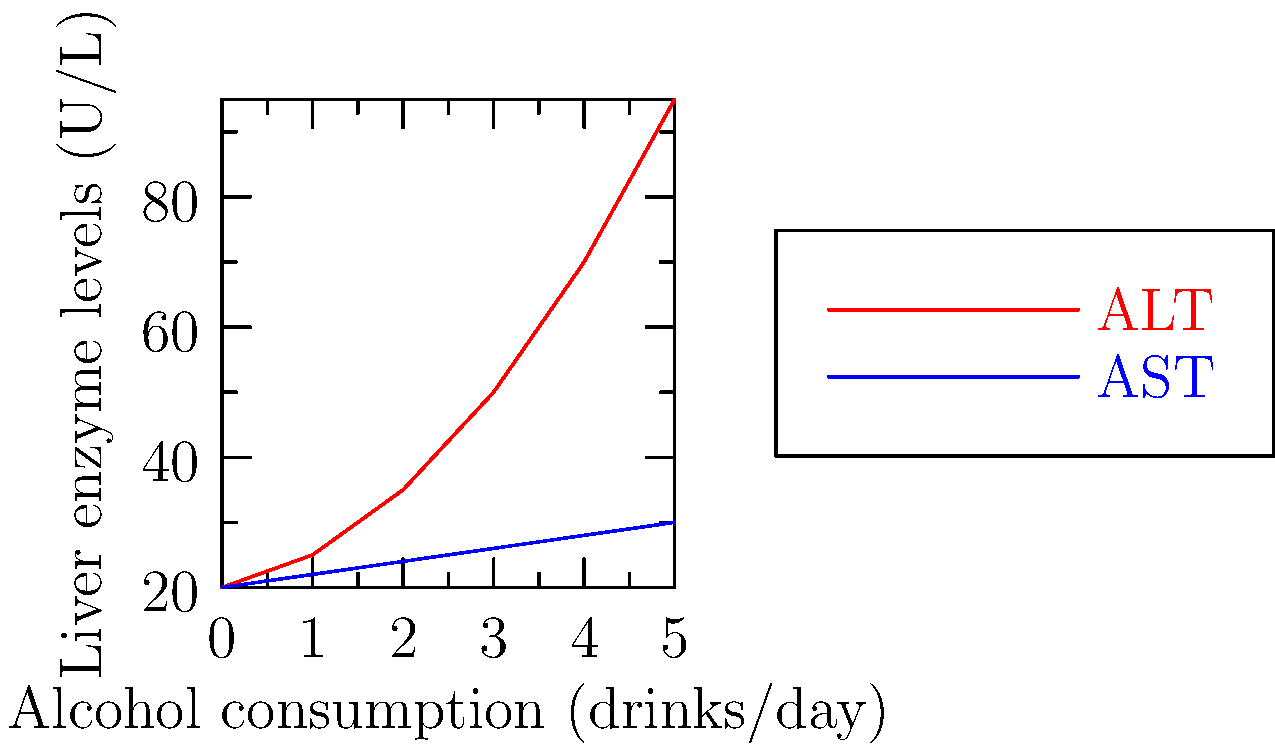Analyze the graph showing the relationship between alcohol consumption and liver enzyme levels (ALT and AST). What conclusion can be drawn about the impact of increasing alcohol intake on liver health? To analyze this graph and draw conclusions about liver health, we need to consider the following steps:

1. Identify the variables:
   - X-axis: Alcohol consumption (drinks/day)
   - Y-axis: Liver enzyme levels (U/L)
   - Red line: ALT (Alanine Aminotransferase)
   - Blue line: AST (Aspartate Aminotransferase)

2. Observe the trends:
   - ALT (red line): Shows a sharp increase as alcohol consumption increases
   - AST (blue line): Shows a gradual increase as alcohol consumption increases

3. Interpret the enzyme changes:
   - ALT and AST are enzymes found primarily in the liver
   - Elevated levels of these enzymes indicate liver cell damage or inflammation

4. Analyze the relationship:
   - As alcohol consumption increases, both ALT and AST levels rise
   - ALT shows a more dramatic increase compared to AST
   - This suggests that alcohol consumption has a more significant impact on ALT levels

5. Consider the implications for liver health:
   - The rising enzyme levels indicate increasing liver cell damage with higher alcohol intake
   - The steeper increase in ALT suggests that it may be a more sensitive indicator of alcohol-induced liver damage

6. Draw a conclusion:
   - Increasing alcohol consumption is associated with elevated liver enzyme levels, particularly ALT
   - This relationship suggests that higher alcohol intake leads to progressively worsening liver health and potential liver damage
Answer: Increasing alcohol consumption is associated with elevated liver enzyme levels, particularly ALT, indicating progressively worsening liver health and potential liver damage. 